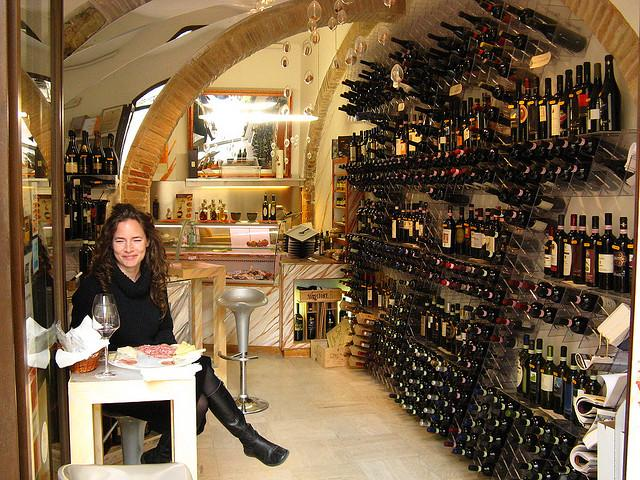What is the woman surrounded by? wine 